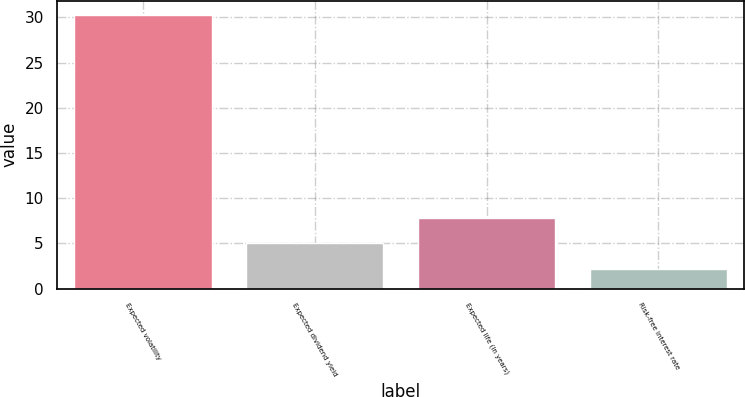Convert chart to OTSL. <chart><loc_0><loc_0><loc_500><loc_500><bar_chart><fcel>Expected volatility<fcel>Expected dividend yield<fcel>Expected life (in years)<fcel>Risk-free interest rate<nl><fcel>30.3<fcel>5.01<fcel>7.82<fcel>2.2<nl></chart> 